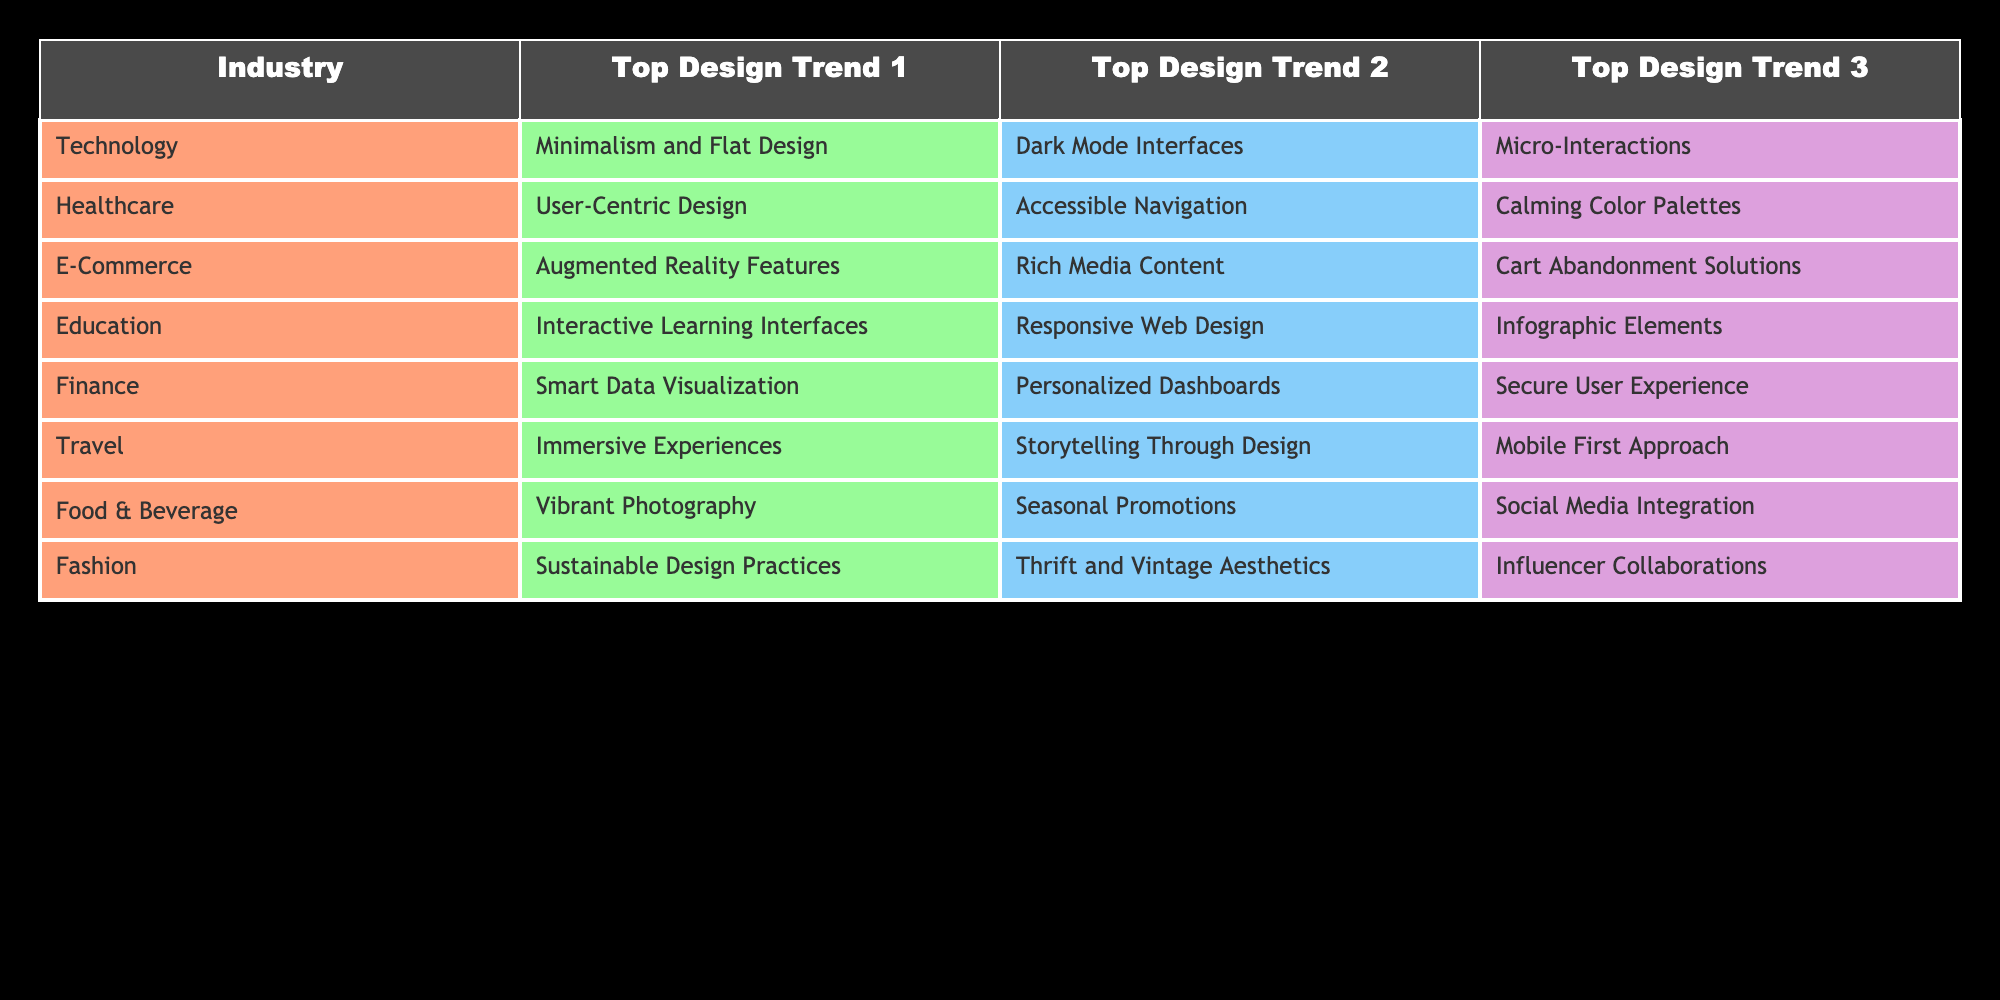What are the top design trends for the Technology industry? The table lists three trends under the Technology industry: Minimalism and Flat Design, Dark Mode Interfaces, and Micro-Interactions. Since these are directly seen in the relevant row of the table, the answer can be retrieved straightforwardly.
Answer: Minimalism and Flat Design, Dark Mode Interfaces, Micro-Interactions Which industry focuses on User-Centric Design as a top trend? By looking at the table, User-Centric Design is listed as the first trend under the Healthcare industry. It can be identified directly from the row corresponding to Healthcare.
Answer: Healthcare How many design trends are listed for the Food & Beverage industry? There are three design trends provided for the Food & Beverage industry: Vibrant Photography, Seasonal Promotions, and Social Media Integration. By counting these trends from the relevant row, we determine the total is three.
Answer: 3 Is Augmented Reality Features a trend for Finance? The table indicates that Augmented Reality Features is one of the top trends under the E-Commerce industry, not Finance. Since it is not present under Finance, the answer is straightforward.
Answer: No Which design trends are shared between E-Commerce and Travel industries? The table shows that E-Commerce has Augmented Reality Features, Rich Media Content, and Cart Abandonment Solutions, while Travel's trends are Immersive Experiences, Storytelling Through Design, and Mobile First Approach. Upon reviewing, there are no shared design trends between these industries, leading to the conclusion with clarity.
Answer: None What is the total number of unique design trends across all industries? Counting the unique design trends from each industry listed in the table (there are 3 for each of the 8 industries) gives us a total of 24 trends. To find the unique count, we identify and remove duplicates found in the three trends of each industry, ensuring accuracy. The unique trends include Minimalism and Flat Design, Dark Mode Interfaces, Micro-Interactions, etc., each counted only once. Thus, the total number of unique trends is 20.
Answer: 20 Which industry has the trend 'Sustainable Design Practices'? The trend 'Sustainable Design Practices' is specifically listed under the Fashion industry in the table. This value is retrieved directly from the table based on the corresponding row, confirming the accuracy.
Answer: Fashion How many trends listed under Finance emphasize user experience and data visualization? The Finance industry has Smart Data Visualization and Personalized Dashboards, both focusing on user experience in terms of visual and interactive data representation. By reviewing the trends provided, we find that there are two that emphasize this aspect.
Answer: 2 What is the first design trend for the Education industry? Looking up the table under Education, the first design trend listed is Interactive Learning Interfaces. This is retrieved directly from the specific row for Education without needing further computation.
Answer: Interactive Learning Interfaces 